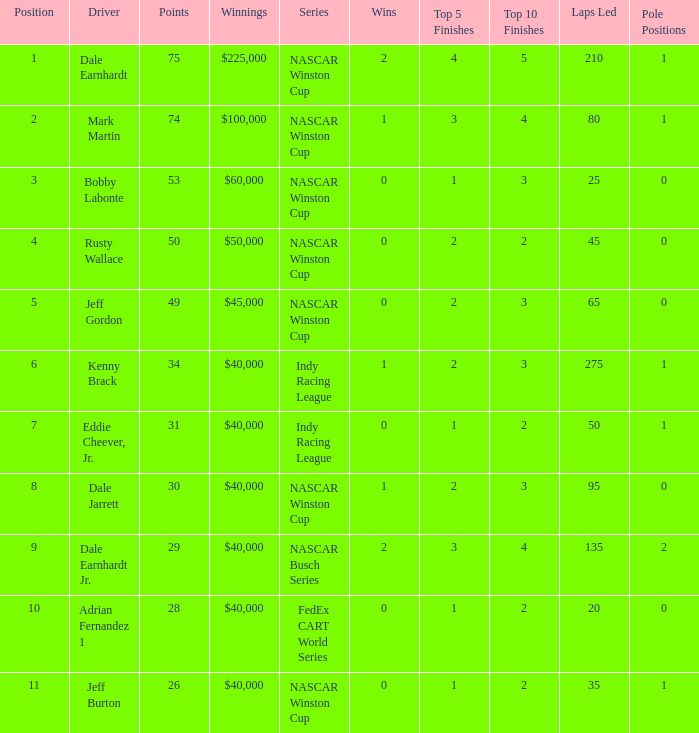What position did the driver earn 31 points? 7.0. 